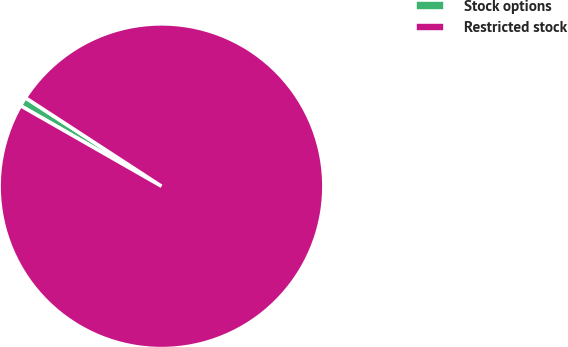Convert chart to OTSL. <chart><loc_0><loc_0><loc_500><loc_500><pie_chart><fcel>Stock options<fcel>Restricted stock<nl><fcel>0.92%<fcel>99.08%<nl></chart> 